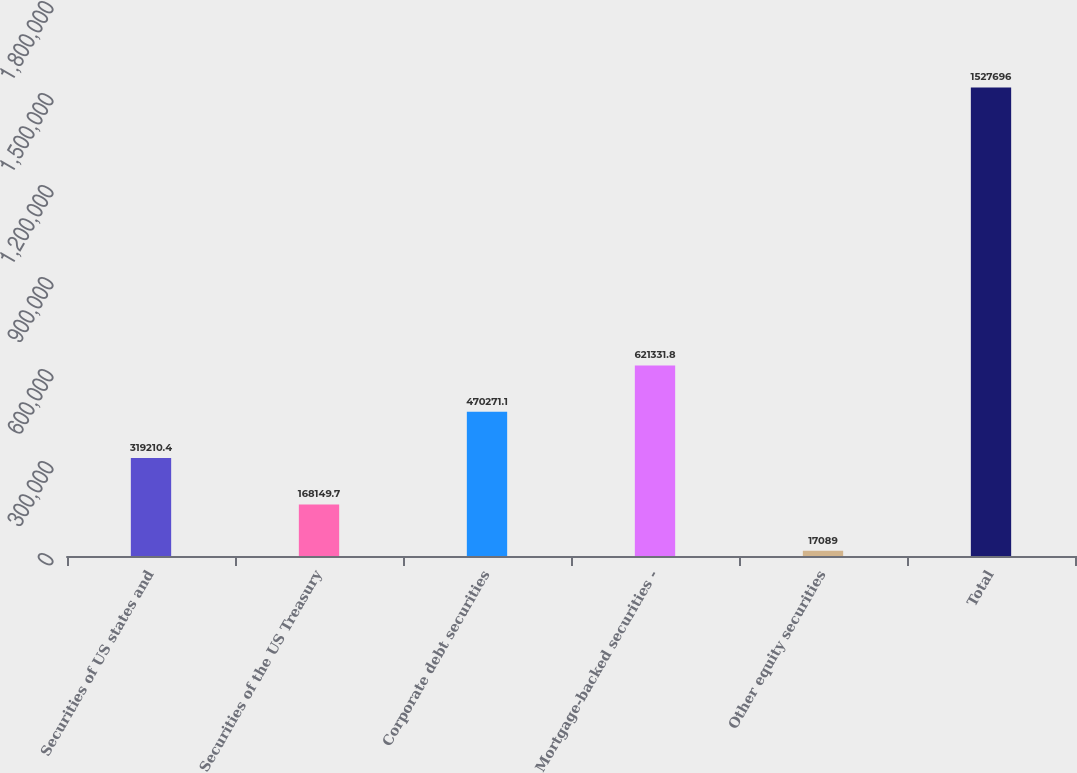<chart> <loc_0><loc_0><loc_500><loc_500><bar_chart><fcel>Securities of US states and<fcel>Securities of the US Treasury<fcel>Corporate debt securities<fcel>Mortgage-backed securities -<fcel>Other equity securities<fcel>Total<nl><fcel>319210<fcel>168150<fcel>470271<fcel>621332<fcel>17089<fcel>1.5277e+06<nl></chart> 